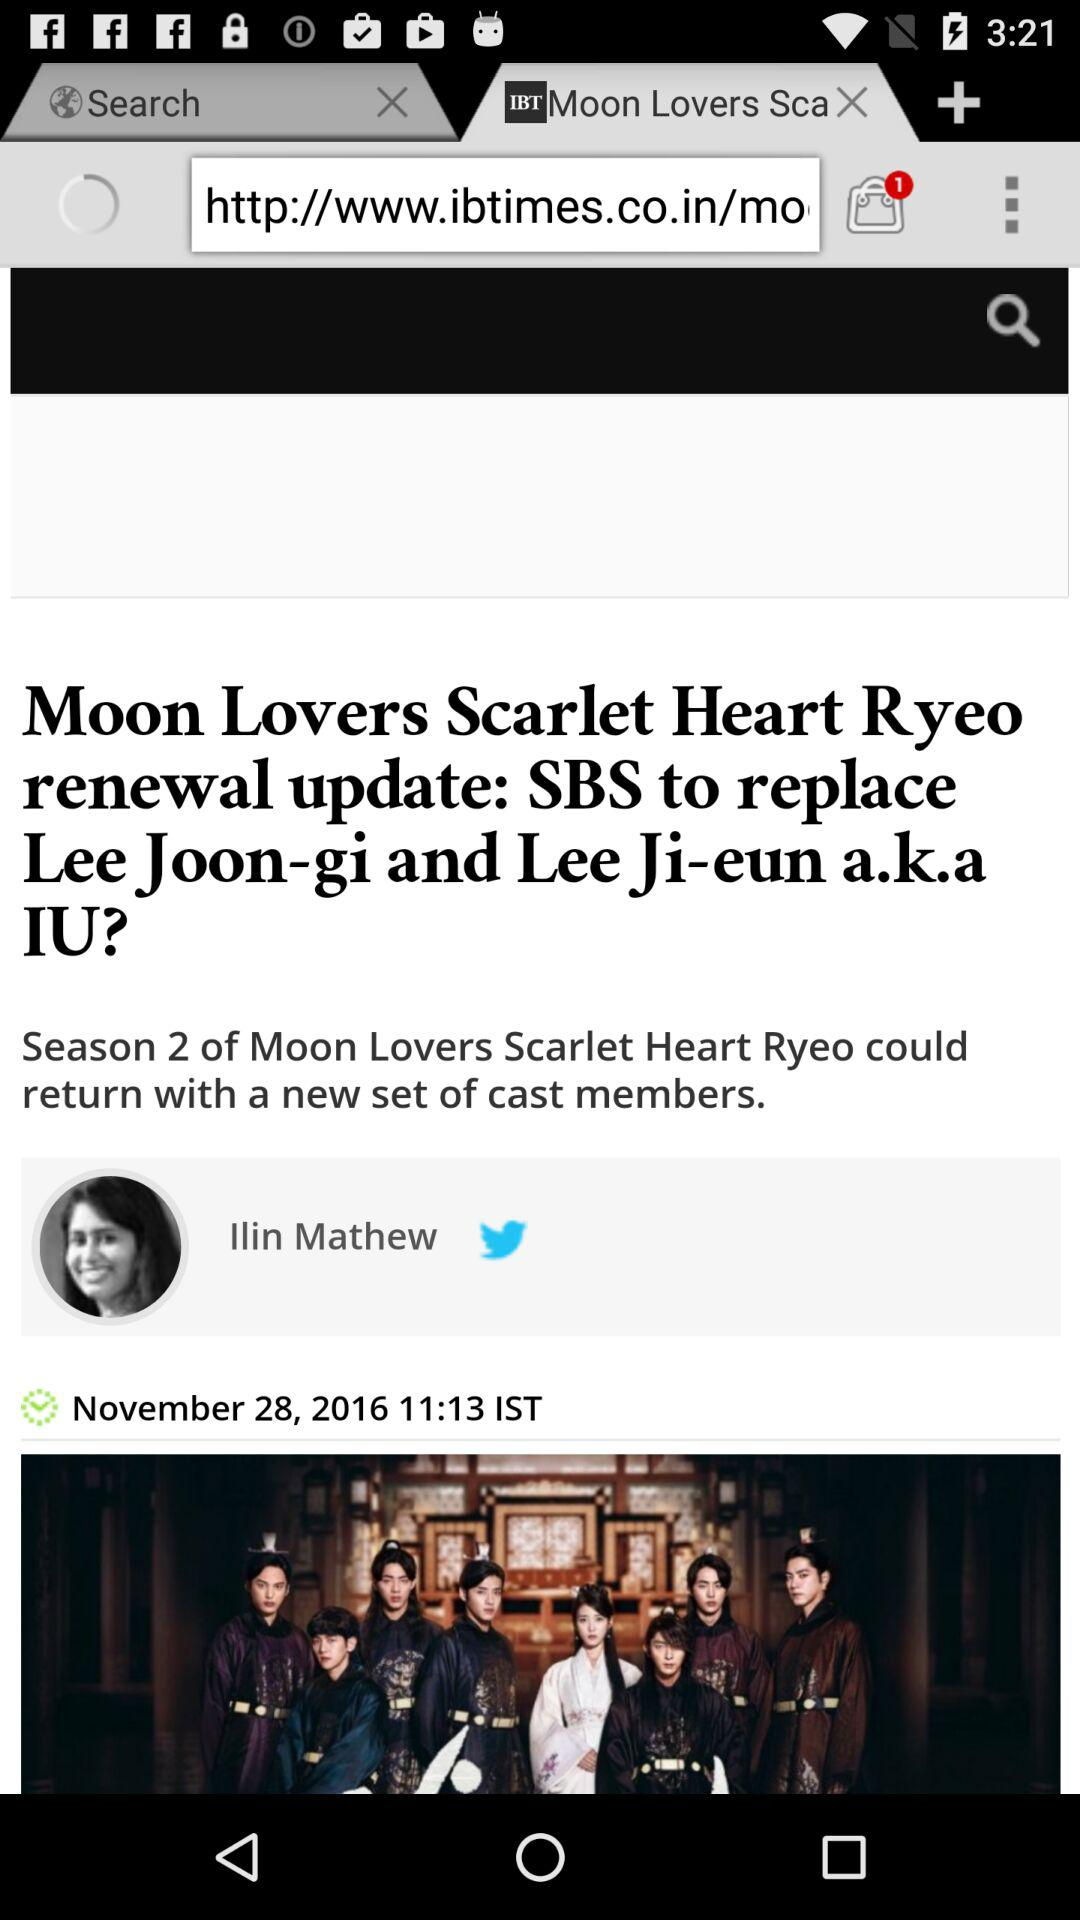What is the publication date? The publication date is November 28, 2016. 